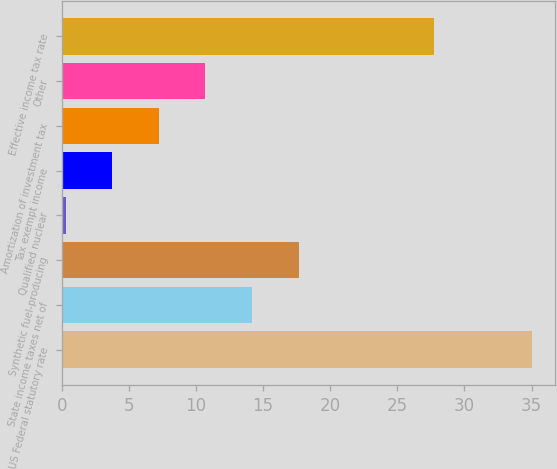<chart> <loc_0><loc_0><loc_500><loc_500><bar_chart><fcel>US Federal statutory rate<fcel>State income taxes net of<fcel>Synthetic fuel-producing<fcel>Qualified nuclear<fcel>Tax exempt income<fcel>Amortization of investment tax<fcel>Other<fcel>Effective income tax rate<nl><fcel>35<fcel>14.18<fcel>17.65<fcel>0.3<fcel>3.77<fcel>7.24<fcel>10.71<fcel>27.7<nl></chart> 